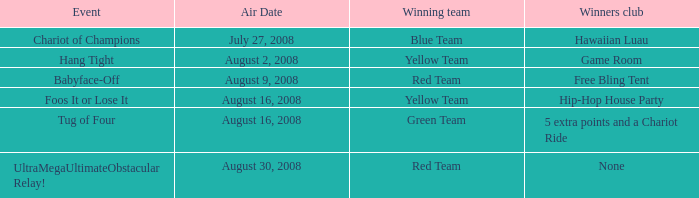Which conquerors club has an event of grip firmly? Game Room. 